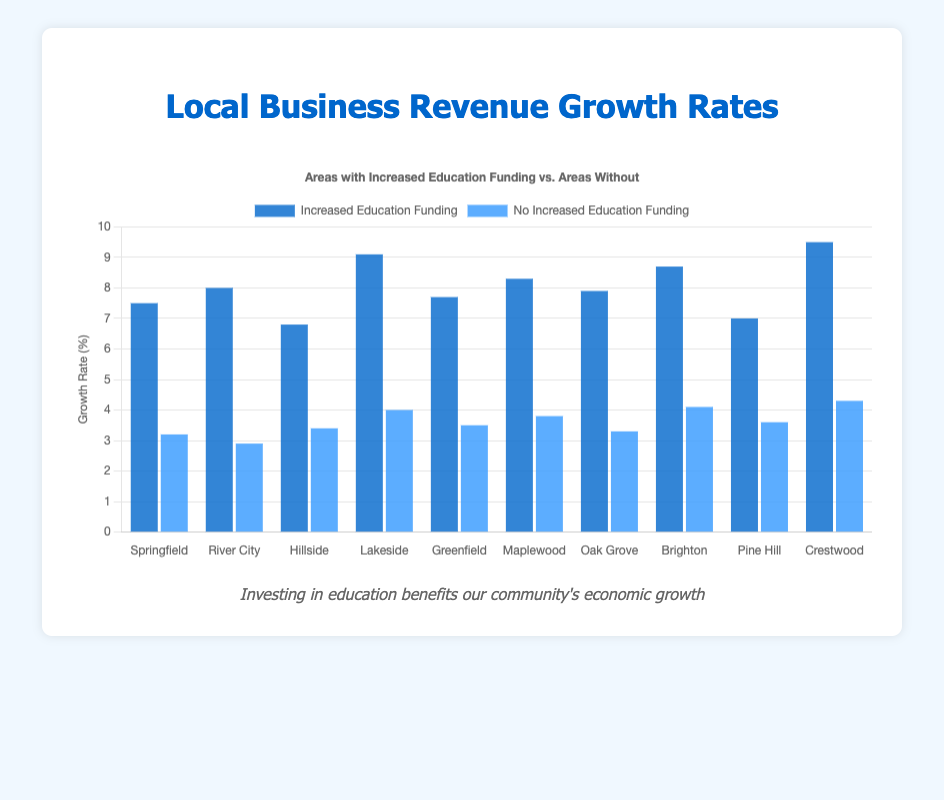Which area has the highest revenue growth rate with increased education funding? Crestwood has a revenue growth rate of 9.5% with increased education funding, which is the highest among all the areas.
Answer: Crestwood What is the difference in revenue growth rate between areas with increased and no increased education funding for Maplewood? The revenue growth rate for Maplewood with increased education funding is 8.3%, and without it, it is 3.8%. The difference is calculated as 8.3% - 3.8% = 4.5%.
Answer: 4.5% Which area has the smallest difference in growth rates between increased and no increased education funding? Crestwood's growth rates are 9.5% (increased) and 4.3% (no increased), with a difference of 9.5% - 4.3% = 5.2%. All other areas have a higher difference.
Answer: Crestwood Identify the area with the lowest growth rate without increased education funding. River City has the lowest growth rate without increased education funding, which is 2.9%.
Answer: River City What is the average revenue growth rate for areas with increased education funding? The sum of revenue growth rates for areas with increased education funding is 7.5 + 8.0 + 6.8 + 9.1 + 7.7 + 8.3 + 7.9 + 8.7 + 7.0 + 9.5 = 80.5%. There are 10 areas, so the average is 80.5 / 10 = 8.05%.
Answer: 8.05% Is there any area where the revenue growth rate with increased education funding is less than 7%? Pine Hill has a revenue growth rate of 7.0% and Hillside has 6.8% with increased education funding, both of which are less than 7%.
Answer: Yes Compare the revenue growth rates for Brighton and Lakeside with and without increased education funding. Brighton: Increased = 8.7%, No Increased = 4.1%. Lakeside: Increased = 9.1%, No Increased = 4.0%. Brighton has slightly lower growth with increased funding and slightly higher without.
Answer: Brighton lower with increased, higher without How much more is the revenue growth rate in Springfield with increased education funding compared to without? Springfield's rates are 7.5% (increased) and 3.2% (no increased). The difference is 7.5% - 3.2% = 4.3%.
Answer: 4.3% What is the total revenue growth rate for River City and Crestwood with increased education funding? River City's rate is 8.0% and Crestwood's is 9.5%. The total is 8.0% + 9.5% = 17.5%.
Answer: 17.5% How does the color coding differentiate between the two types of funding in the chart? The bars representing increased education funding are dark blue, while those for no increased funding are blue.
Answer: Dark blue and blue 